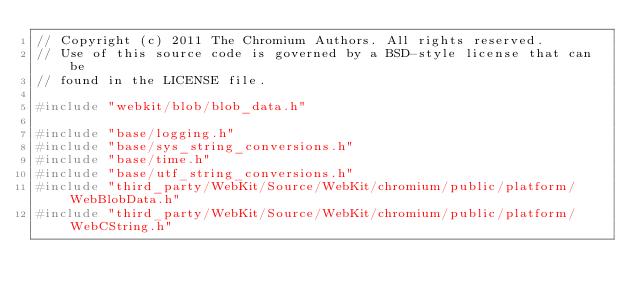Convert code to text. <code><loc_0><loc_0><loc_500><loc_500><_C++_>// Copyright (c) 2011 The Chromium Authors. All rights reserved.
// Use of this source code is governed by a BSD-style license that can be
// found in the LICENSE file.

#include "webkit/blob/blob_data.h"

#include "base/logging.h"
#include "base/sys_string_conversions.h"
#include "base/time.h"
#include "base/utf_string_conversions.h"
#include "third_party/WebKit/Source/WebKit/chromium/public/platform/WebBlobData.h"
#include "third_party/WebKit/Source/WebKit/chromium/public/platform/WebCString.h"</code> 